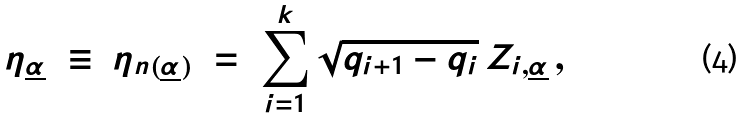Convert formula to latex. <formula><loc_0><loc_0><loc_500><loc_500>\eta _ { \underline { \alpha } } \ \equiv \ \eta _ { n ( \underline { \alpha } ) } \ = \ \sum _ { i = 1 } ^ { k } \sqrt { q _ { i + 1 } - q _ { i } } \, Z _ { i , \underline { \alpha } } \, ,</formula> 